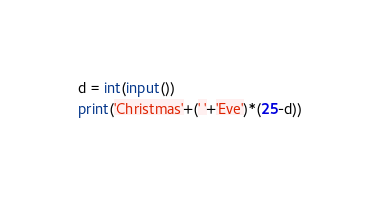Convert code to text. <code><loc_0><loc_0><loc_500><loc_500><_Python_>d = int(input())
print('Christmas'+(' '+'Eve')*(25-d))</code> 